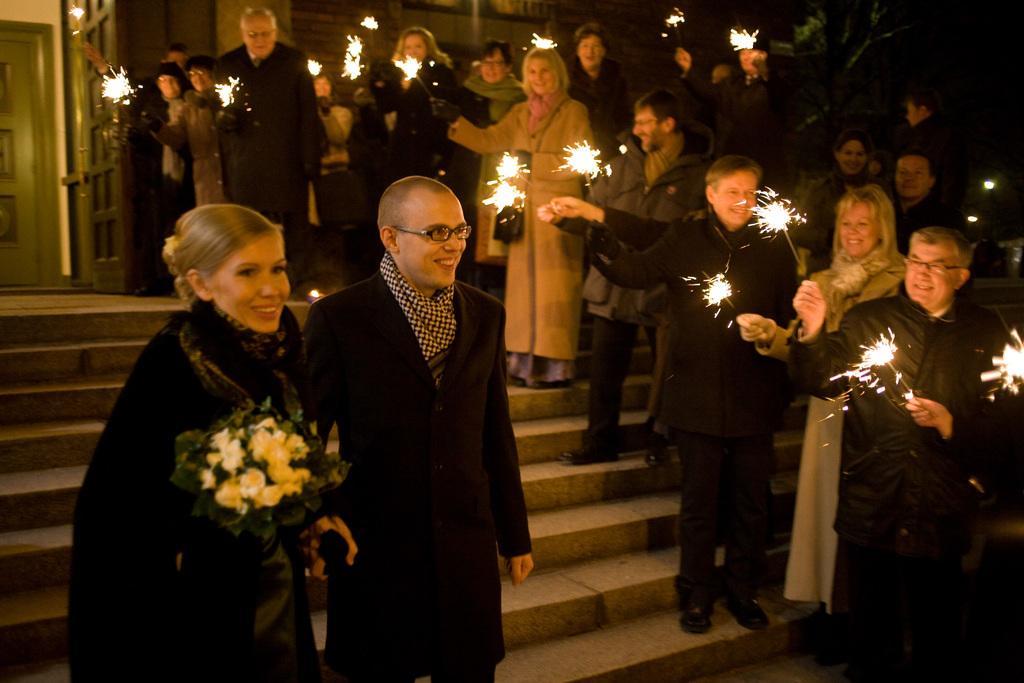How would you summarize this image in a sentence or two? In this image I can see group of people standing and they are holding few fireworks. In front the person is holding the bouquet. In the background I can see two doors. 